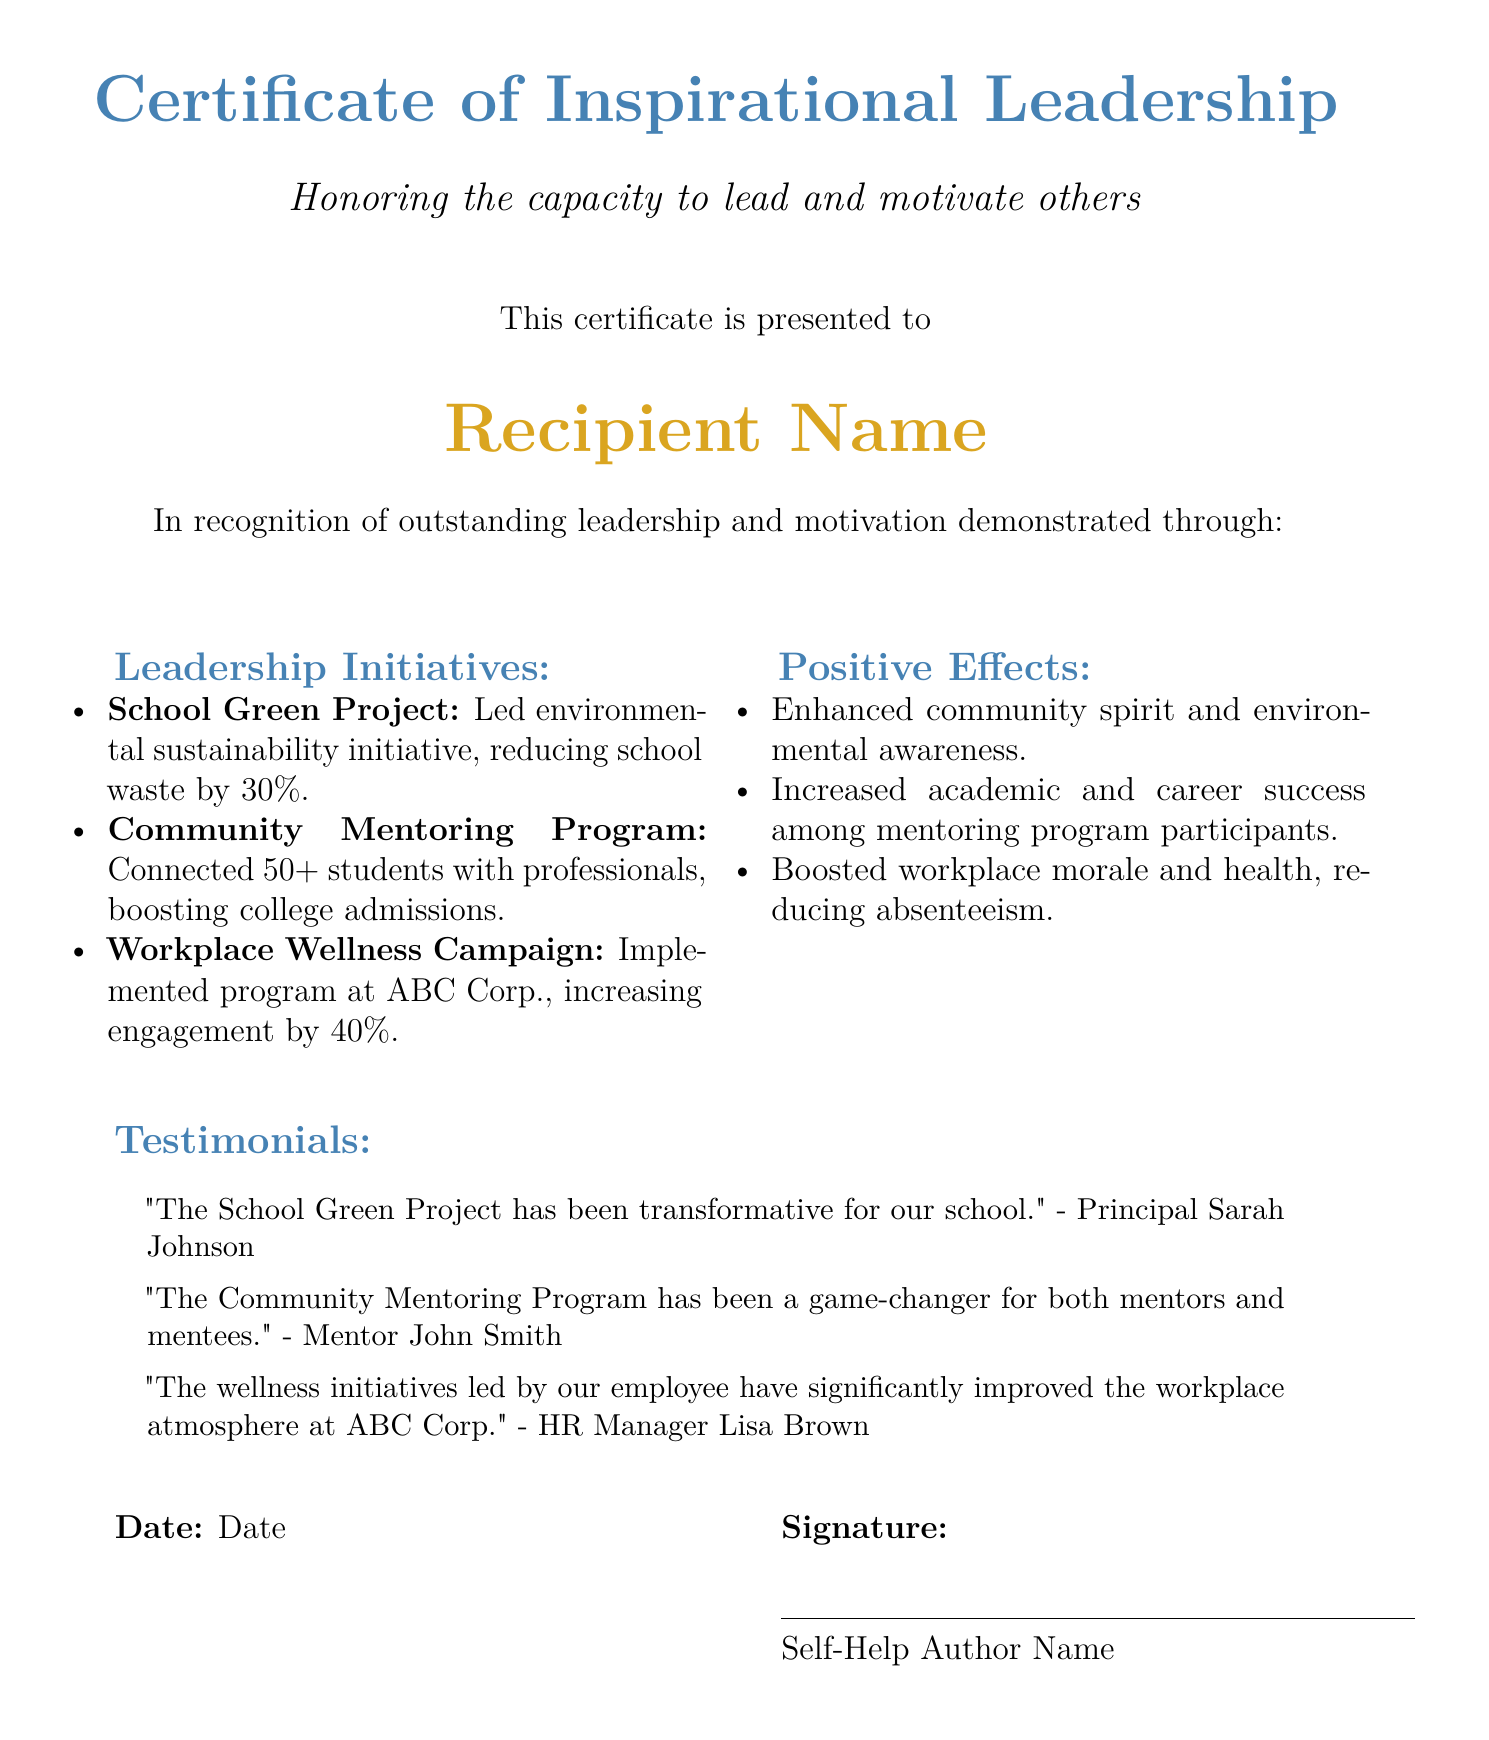What is the title of the certificate? The title of the certificate is prominently displayed at the top of the document as "Certificate of Inspirational Leadership."
Answer: Certificate of Inspirational Leadership Who is the certificate presented to? The recipient's name is specified in the document after the phrase "This certificate is presented to."
Answer: Recipient Name What is the percentage of school waste reduction achieved through the School Green Project? The document states that the School Green Project led to a reduction in school waste by 30%.
Answer: 30% How many students were connected to professionals through the Community Mentoring Program? The document mentions that the Community Mentoring Program connected over 50 students with professionals.
Answer: 50+ Who provided a testimonial about the Community Mentoring Program? A mentor named John Smith is credited with providing a testimonial about the Community Mentoring Program.
Answer: Mentor John Smith What was the positive effect of the Workplace Wellness Campaign? The document indicates that the Workplace Wellness Campaign boosted workplace morale and health, reducing absenteeism.
Answer: Reduced absenteeism Which project led to an increase in college admissions? The Community Mentoring Program is identified as the initiative that boosted college admissions among participants.
Answer: Community Mentoring Program What color is used for the section headers? The section headers are presented in the color defined as inspiration blue.
Answer: inspiration blue Who signed the certificate? The document indicates that it is signed by "Self-Help Author Name."
Answer: Self-Help Author Name 